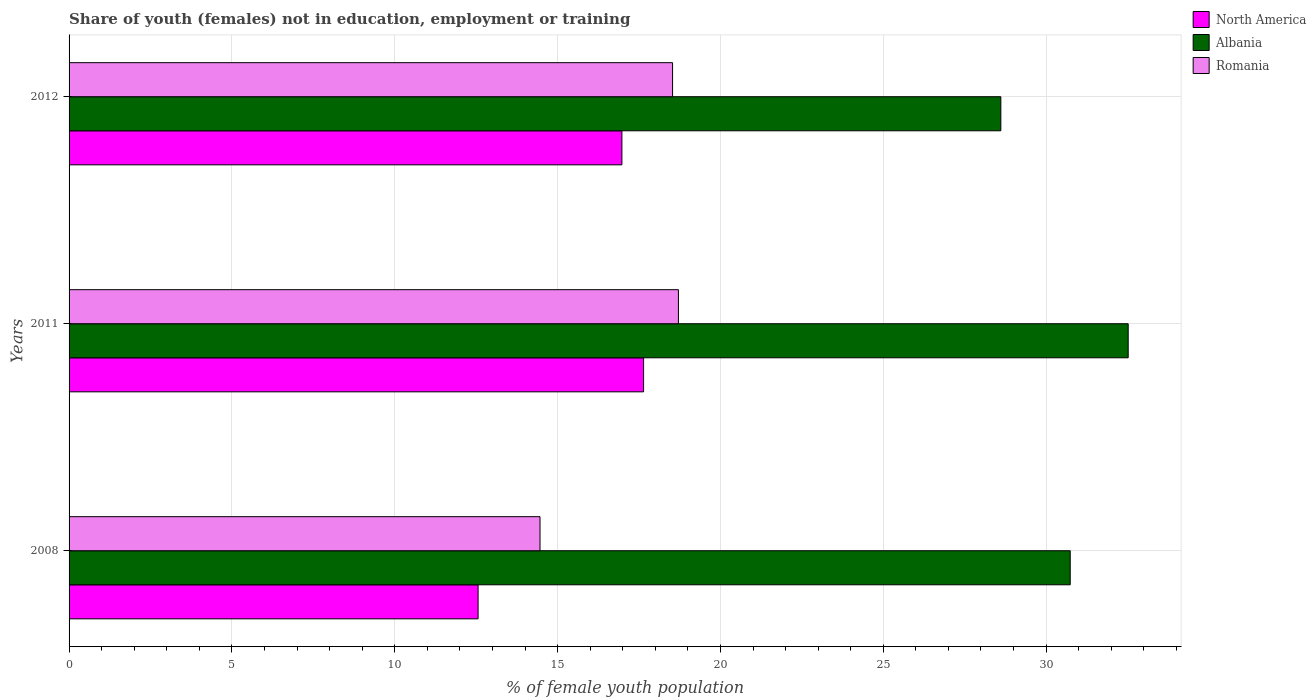How many groups of bars are there?
Keep it short and to the point. 3. How many bars are there on the 2nd tick from the top?
Provide a succinct answer. 3. How many bars are there on the 3rd tick from the bottom?
Ensure brevity in your answer.  3. What is the label of the 3rd group of bars from the top?
Your answer should be very brief. 2008. What is the percentage of unemployed female population in in Albania in 2012?
Make the answer very short. 28.61. Across all years, what is the maximum percentage of unemployed female population in in Albania?
Provide a short and direct response. 32.52. Across all years, what is the minimum percentage of unemployed female population in in Romania?
Ensure brevity in your answer.  14.46. What is the total percentage of unemployed female population in in Romania in the graph?
Provide a short and direct response. 51.7. What is the difference between the percentage of unemployed female population in in Albania in 2008 and that in 2011?
Ensure brevity in your answer.  -1.78. What is the difference between the percentage of unemployed female population in in North America in 2011 and the percentage of unemployed female population in in Romania in 2012?
Offer a terse response. -0.89. What is the average percentage of unemployed female population in in Romania per year?
Offer a very short reply. 17.23. In the year 2012, what is the difference between the percentage of unemployed female population in in Albania and percentage of unemployed female population in in Romania?
Provide a succinct answer. 10.08. What is the ratio of the percentage of unemployed female population in in Albania in 2008 to that in 2012?
Offer a terse response. 1.07. Is the percentage of unemployed female population in in North America in 2008 less than that in 2012?
Your response must be concise. Yes. What is the difference between the highest and the second highest percentage of unemployed female population in in Romania?
Your response must be concise. 0.18. What is the difference between the highest and the lowest percentage of unemployed female population in in Albania?
Give a very brief answer. 3.91. In how many years, is the percentage of unemployed female population in in Romania greater than the average percentage of unemployed female population in in Romania taken over all years?
Your answer should be compact. 2. What does the 1st bar from the top in 2012 represents?
Offer a terse response. Romania. What does the 3rd bar from the bottom in 2011 represents?
Provide a short and direct response. Romania. Is it the case that in every year, the sum of the percentage of unemployed female population in in Albania and percentage of unemployed female population in in North America is greater than the percentage of unemployed female population in in Romania?
Offer a terse response. Yes. How many years are there in the graph?
Give a very brief answer. 3. What is the difference between two consecutive major ticks on the X-axis?
Provide a succinct answer. 5. Where does the legend appear in the graph?
Provide a succinct answer. Top right. How are the legend labels stacked?
Your answer should be compact. Vertical. What is the title of the graph?
Ensure brevity in your answer.  Share of youth (females) not in education, employment or training. Does "Virgin Islands" appear as one of the legend labels in the graph?
Give a very brief answer. No. What is the label or title of the X-axis?
Your answer should be compact. % of female youth population. What is the % of female youth population in North America in 2008?
Ensure brevity in your answer.  12.56. What is the % of female youth population in Albania in 2008?
Make the answer very short. 30.74. What is the % of female youth population of Romania in 2008?
Ensure brevity in your answer.  14.46. What is the % of female youth population of North America in 2011?
Your answer should be very brief. 17.64. What is the % of female youth population of Albania in 2011?
Your answer should be compact. 32.52. What is the % of female youth population of Romania in 2011?
Your answer should be very brief. 18.71. What is the % of female youth population in North America in 2012?
Provide a short and direct response. 16.97. What is the % of female youth population in Albania in 2012?
Keep it short and to the point. 28.61. What is the % of female youth population in Romania in 2012?
Offer a terse response. 18.53. Across all years, what is the maximum % of female youth population of North America?
Make the answer very short. 17.64. Across all years, what is the maximum % of female youth population in Albania?
Offer a terse response. 32.52. Across all years, what is the maximum % of female youth population of Romania?
Your answer should be compact. 18.71. Across all years, what is the minimum % of female youth population in North America?
Your answer should be compact. 12.56. Across all years, what is the minimum % of female youth population of Albania?
Your answer should be compact. 28.61. Across all years, what is the minimum % of female youth population in Romania?
Your answer should be compact. 14.46. What is the total % of female youth population in North America in the graph?
Provide a short and direct response. 47.17. What is the total % of female youth population in Albania in the graph?
Give a very brief answer. 91.87. What is the total % of female youth population of Romania in the graph?
Your answer should be compact. 51.7. What is the difference between the % of female youth population in North America in 2008 and that in 2011?
Provide a short and direct response. -5.08. What is the difference between the % of female youth population of Albania in 2008 and that in 2011?
Offer a terse response. -1.78. What is the difference between the % of female youth population in Romania in 2008 and that in 2011?
Ensure brevity in your answer.  -4.25. What is the difference between the % of female youth population of North America in 2008 and that in 2012?
Your answer should be very brief. -4.42. What is the difference between the % of female youth population of Albania in 2008 and that in 2012?
Keep it short and to the point. 2.13. What is the difference between the % of female youth population in Romania in 2008 and that in 2012?
Offer a terse response. -4.07. What is the difference between the % of female youth population in North America in 2011 and that in 2012?
Your response must be concise. 0.67. What is the difference between the % of female youth population in Albania in 2011 and that in 2012?
Give a very brief answer. 3.91. What is the difference between the % of female youth population of Romania in 2011 and that in 2012?
Your answer should be very brief. 0.18. What is the difference between the % of female youth population of North America in 2008 and the % of female youth population of Albania in 2011?
Your answer should be compact. -19.96. What is the difference between the % of female youth population of North America in 2008 and the % of female youth population of Romania in 2011?
Provide a short and direct response. -6.15. What is the difference between the % of female youth population of Albania in 2008 and the % of female youth population of Romania in 2011?
Ensure brevity in your answer.  12.03. What is the difference between the % of female youth population in North America in 2008 and the % of female youth population in Albania in 2012?
Give a very brief answer. -16.05. What is the difference between the % of female youth population of North America in 2008 and the % of female youth population of Romania in 2012?
Offer a terse response. -5.97. What is the difference between the % of female youth population of Albania in 2008 and the % of female youth population of Romania in 2012?
Make the answer very short. 12.21. What is the difference between the % of female youth population of North America in 2011 and the % of female youth population of Albania in 2012?
Your response must be concise. -10.97. What is the difference between the % of female youth population in North America in 2011 and the % of female youth population in Romania in 2012?
Give a very brief answer. -0.89. What is the difference between the % of female youth population of Albania in 2011 and the % of female youth population of Romania in 2012?
Provide a succinct answer. 13.99. What is the average % of female youth population of North America per year?
Your answer should be compact. 15.72. What is the average % of female youth population of Albania per year?
Give a very brief answer. 30.62. What is the average % of female youth population of Romania per year?
Make the answer very short. 17.23. In the year 2008, what is the difference between the % of female youth population of North America and % of female youth population of Albania?
Your answer should be very brief. -18.18. In the year 2008, what is the difference between the % of female youth population of North America and % of female youth population of Romania?
Your answer should be compact. -1.9. In the year 2008, what is the difference between the % of female youth population of Albania and % of female youth population of Romania?
Your answer should be very brief. 16.28. In the year 2011, what is the difference between the % of female youth population in North America and % of female youth population in Albania?
Your answer should be very brief. -14.88. In the year 2011, what is the difference between the % of female youth population in North America and % of female youth population in Romania?
Offer a very short reply. -1.07. In the year 2011, what is the difference between the % of female youth population in Albania and % of female youth population in Romania?
Your answer should be compact. 13.81. In the year 2012, what is the difference between the % of female youth population of North America and % of female youth population of Albania?
Your answer should be very brief. -11.64. In the year 2012, what is the difference between the % of female youth population in North America and % of female youth population in Romania?
Provide a short and direct response. -1.56. In the year 2012, what is the difference between the % of female youth population of Albania and % of female youth population of Romania?
Make the answer very short. 10.08. What is the ratio of the % of female youth population of North America in 2008 to that in 2011?
Offer a terse response. 0.71. What is the ratio of the % of female youth population of Albania in 2008 to that in 2011?
Offer a very short reply. 0.95. What is the ratio of the % of female youth population in Romania in 2008 to that in 2011?
Keep it short and to the point. 0.77. What is the ratio of the % of female youth population of North America in 2008 to that in 2012?
Make the answer very short. 0.74. What is the ratio of the % of female youth population in Albania in 2008 to that in 2012?
Make the answer very short. 1.07. What is the ratio of the % of female youth population of Romania in 2008 to that in 2012?
Your answer should be compact. 0.78. What is the ratio of the % of female youth population of North America in 2011 to that in 2012?
Offer a very short reply. 1.04. What is the ratio of the % of female youth population of Albania in 2011 to that in 2012?
Offer a terse response. 1.14. What is the ratio of the % of female youth population in Romania in 2011 to that in 2012?
Your response must be concise. 1.01. What is the difference between the highest and the second highest % of female youth population in North America?
Your answer should be very brief. 0.67. What is the difference between the highest and the second highest % of female youth population of Albania?
Keep it short and to the point. 1.78. What is the difference between the highest and the second highest % of female youth population of Romania?
Offer a terse response. 0.18. What is the difference between the highest and the lowest % of female youth population in North America?
Provide a short and direct response. 5.08. What is the difference between the highest and the lowest % of female youth population in Albania?
Offer a very short reply. 3.91. What is the difference between the highest and the lowest % of female youth population of Romania?
Your answer should be very brief. 4.25. 